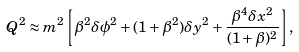Convert formula to latex. <formula><loc_0><loc_0><loc_500><loc_500>Q ^ { 2 } \approx m ^ { 2 } \left [ \beta ^ { 2 } \delta \phi ^ { 2 } + ( 1 + \beta ^ { 2 } ) \delta y ^ { 2 } + \frac { \beta ^ { 4 } \delta x ^ { 2 } } { ( 1 + \beta ) ^ { 2 } } \right ] ,</formula> 